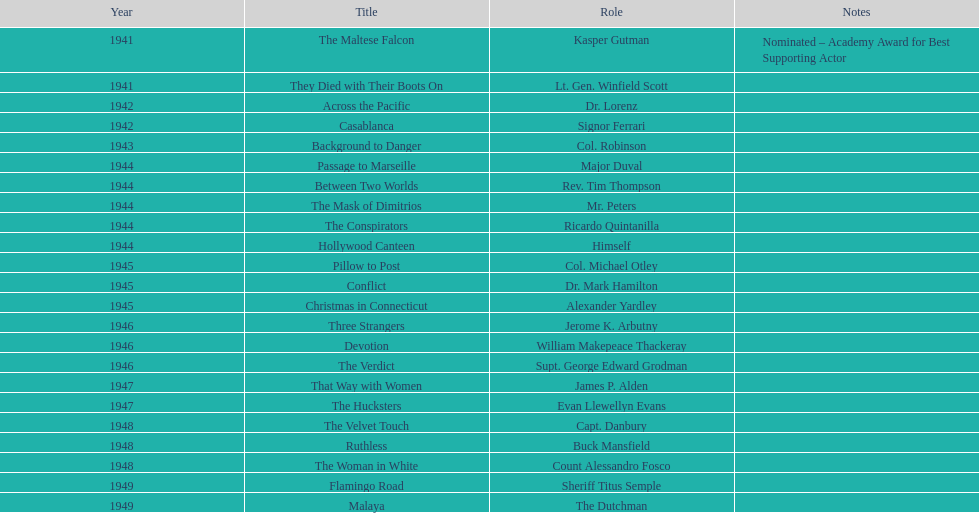In which movie did he earn a nomination for an academy award? The Maltese Falcon. 